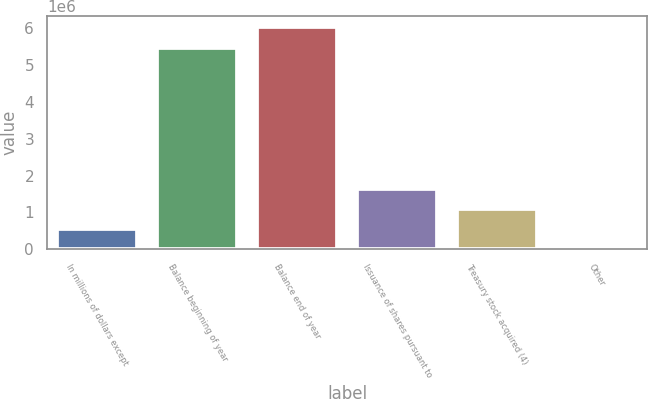Convert chart to OTSL. <chart><loc_0><loc_0><loc_500><loc_500><bar_chart><fcel>In millions of dollars except<fcel>Balance beginning of year<fcel>Balance end of year<fcel>Issuance of shares pursuant to<fcel>Treasury stock acquired (4)<fcel>Other<nl><fcel>548504<fcel>5.47742e+06<fcel>6.02507e+06<fcel>1.64382e+06<fcel>1.09616e+06<fcel>847<nl></chart> 